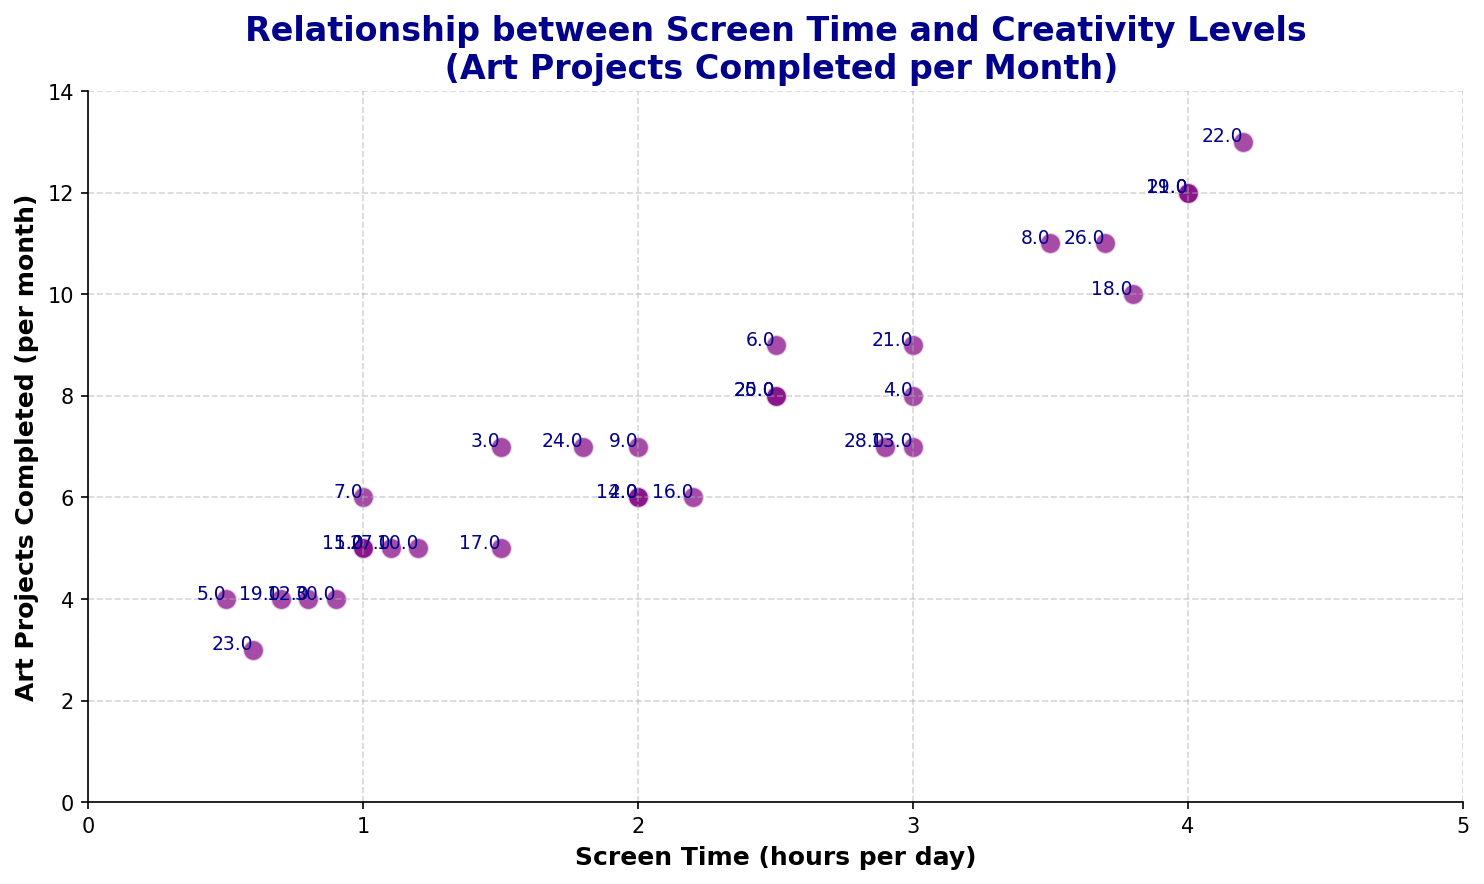what is the trend between screen time and art projects completed? By looking at the scatter plot, there is a general upward trend, meaning that as screen time increases, the number of art projects completed per month also tends to increase. This can be observed by the clustering of data points that show more projects with higher screen time.
Answer: upward trend which student has the highest number of art projects completed? By referring to the annotations in the scatter plot for the art projects completed per month, we see that student 22 has completed the most, with a total of 13 art projects per month.
Answer: student 22 how many students have screen time of 2 hours or more per day and completed at least 8 art projects per month? To answer this question, we count the data points in the scatter plot that meet the criteria of screen time >= 2 hours per day and art projects >= 8 per month. The qualifying students are 6, 18, 21, 25, 26, and 29. Therefore, there are 6 students meeting these criteria.
Answer: 6 students is there a student with 3 hours of screen time per day who completed more than 8 art projects per month? By looking at the scatter plot, we can observe that students with a screen time of exactly 3 hours per day (students 4, 13, and 21) have their art project counts, and student 21 completed 9 art projects per month, which is more than 8.
Answer: yes what is the range of screen time for students who completed 6 art projects per month? From the scatter plot, we can identify that the students who completed 6 art projects per month have screen times of 2, 2.2, and 2.9 hours. Therefore, the range of screen times for these students is from 2 to 2.9 hours.
Answer: 2 to 2.9 hours how does the number of students with less than 1 hour screen time compare to those with more than 3 hours screen time? By examining the scatter plot, we can note that students with less than 1 hour of screen time (students 5, 12, 19, 23, 30) total 5 individuals. Comparatively, those with more than 3 hours of screen time (students 8, 11, 18, 22, 26) also total 5 individuals. Therefore, the numbers are equal.
Answer: equal 